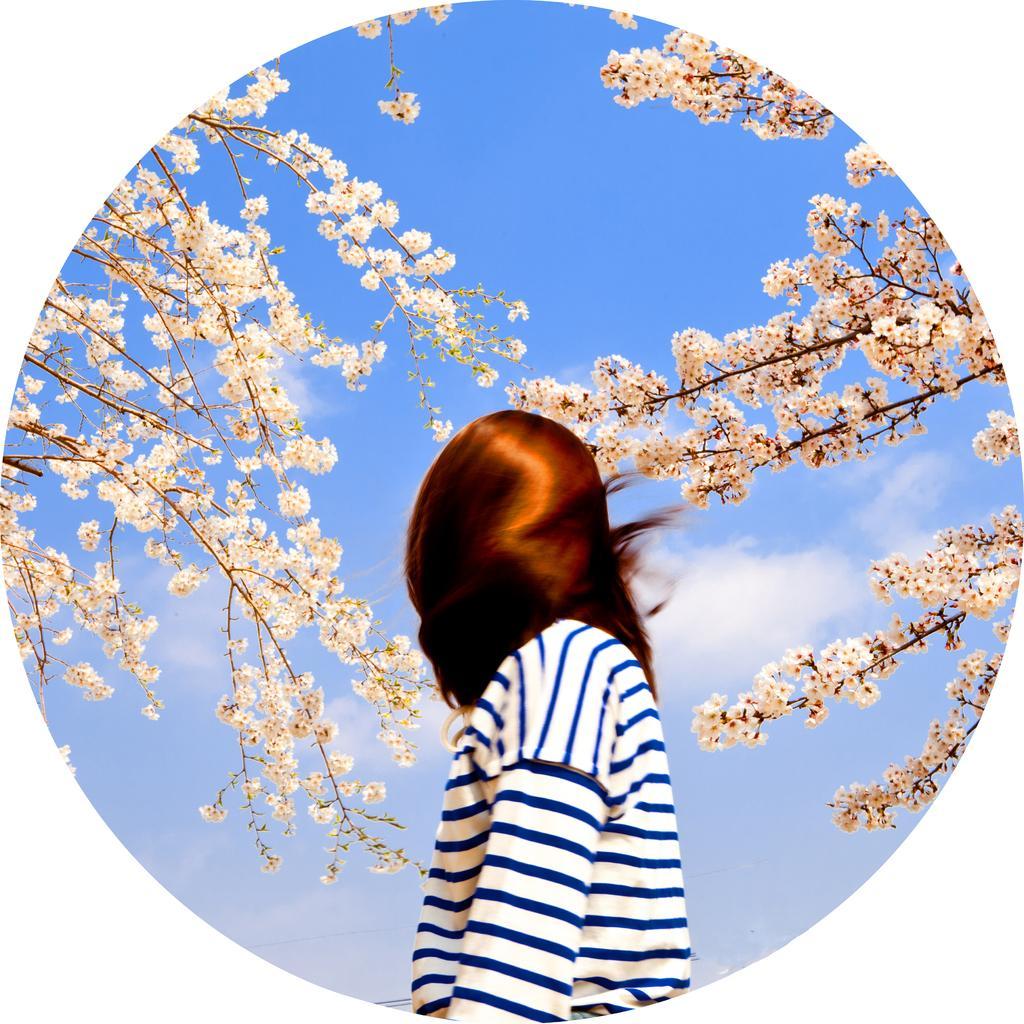Describe this image in one or two sentences. In this image we can see a person. There are branches of trees with flowers. In the background there is sky with clouds. 